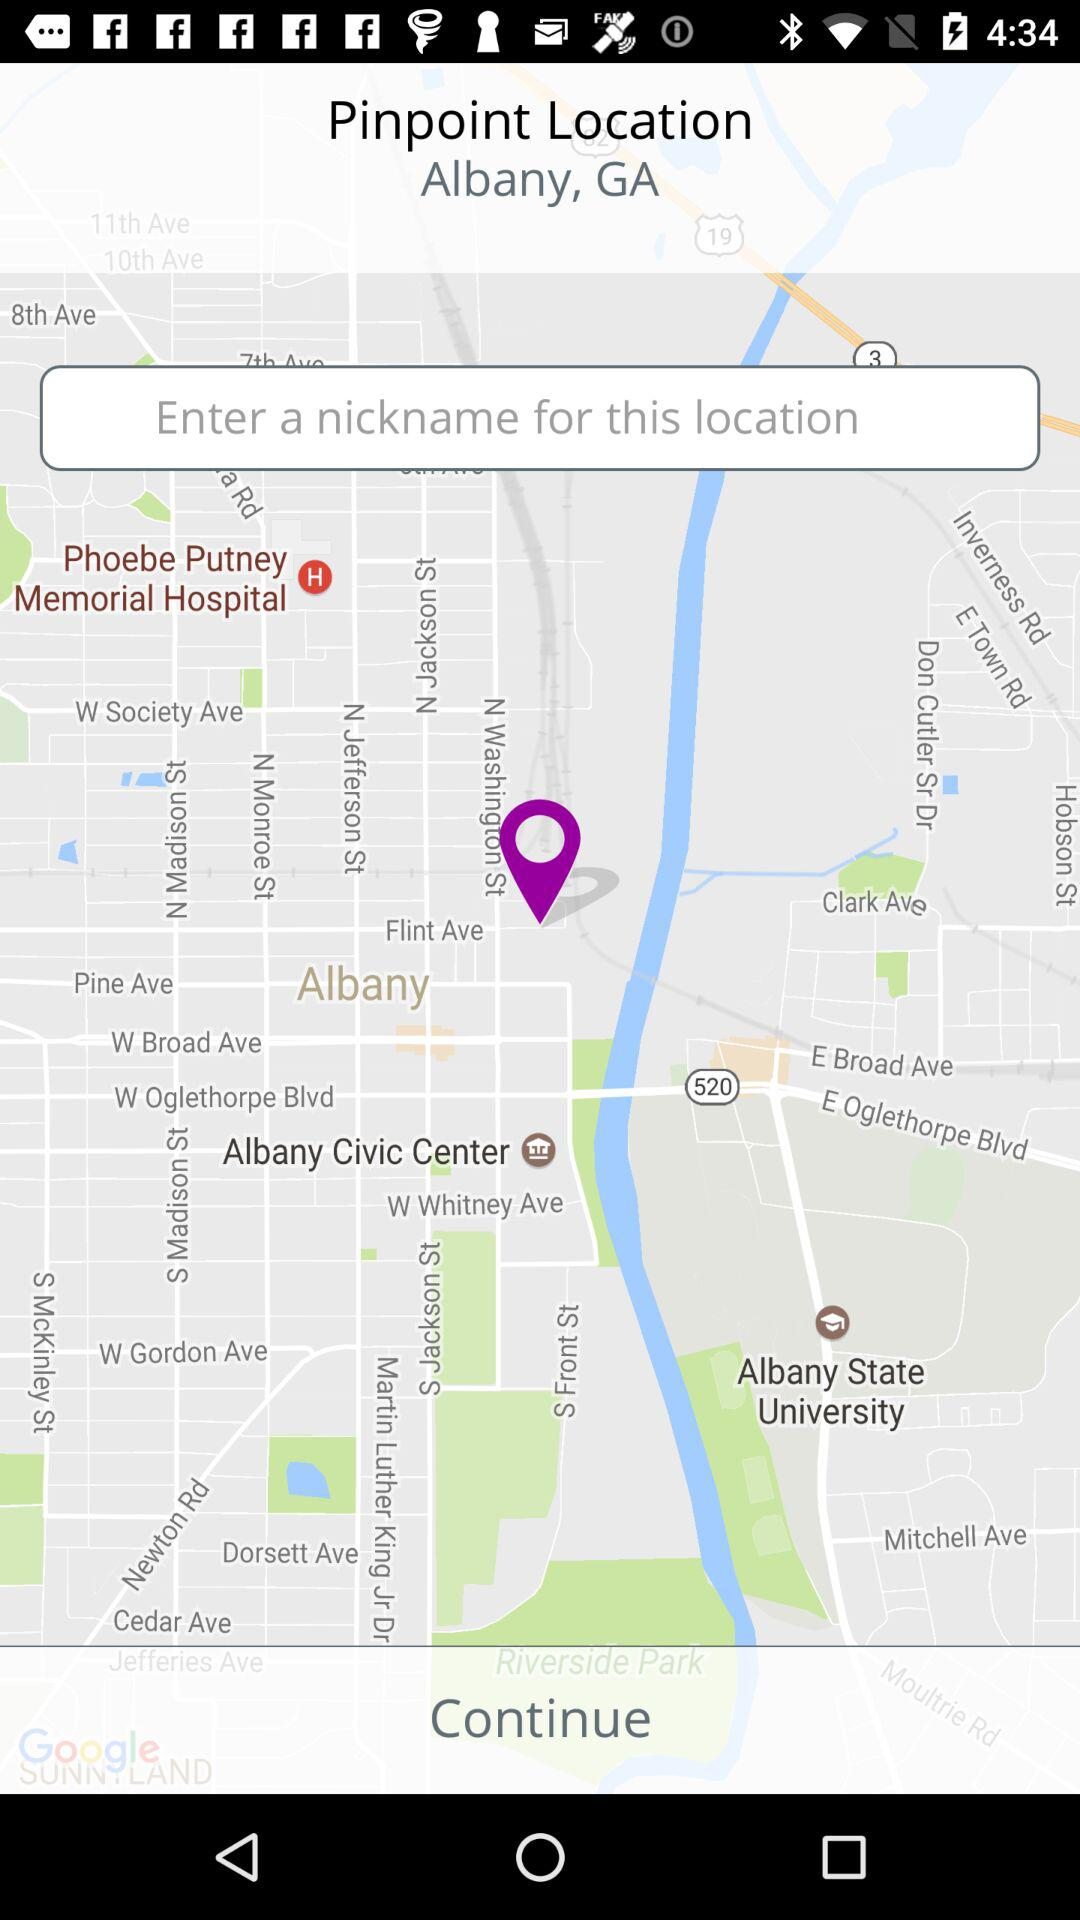What is the pinpoint location? The pinpoint location is Albany, GA. 